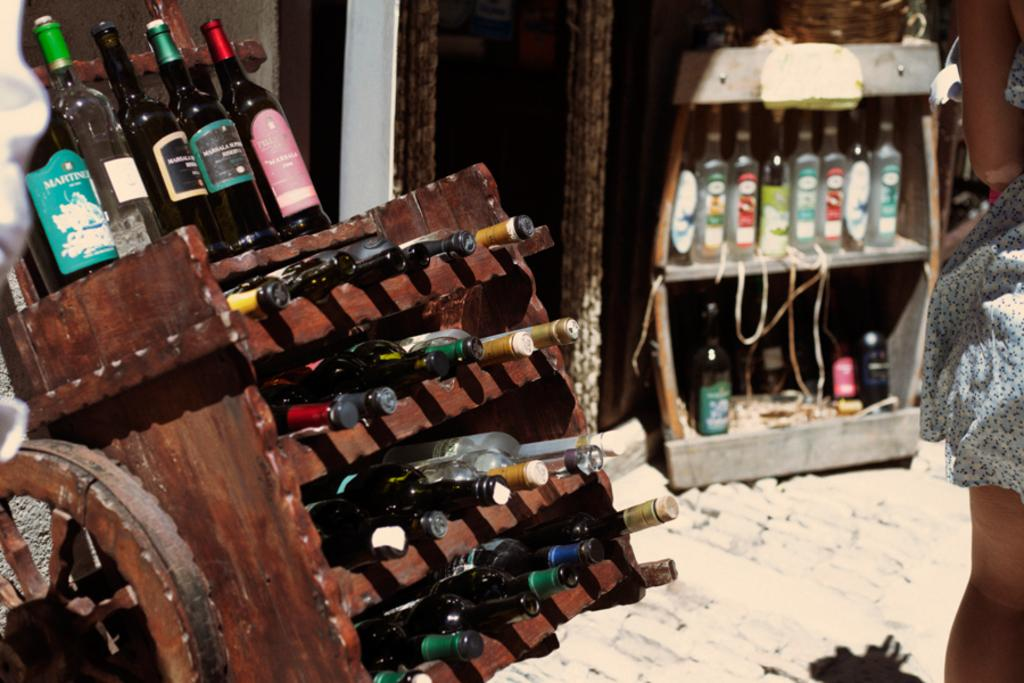What objects are in the image? There are bottles in the image. Where are the bottles located? The bottles are in a rack. What is the rack doing? The rack is moving. On which side of the image is the moving rack? The moving rack is on the left side of the image. What else can be seen in the image? There is a person on the right side of the image. What type of wound can be seen on the hill in the image? There is no hill or wound present in the image. What attraction is visible on the right side of the image? There is no attraction mentioned in the image; only a person is present on the right side. 